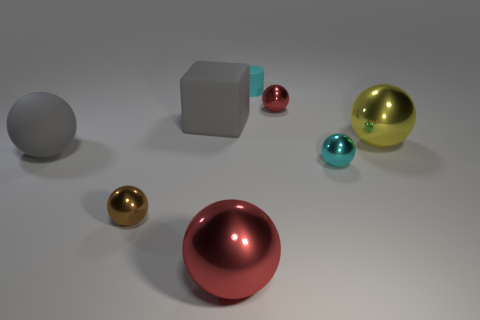Add 2 small red metallic spheres. How many objects exist? 10 Subtract all red blocks. How many red balls are left? 2 Subtract all gray rubber spheres. How many spheres are left? 5 Subtract all gray balls. How many balls are left? 5 Subtract 1 spheres. How many spheres are left? 5 Subtract all blocks. How many objects are left? 7 Subtract 1 cyan balls. How many objects are left? 7 Subtract all brown balls. Subtract all yellow cubes. How many balls are left? 5 Subtract all big yellow metal balls. Subtract all purple balls. How many objects are left? 7 Add 8 big gray rubber blocks. How many big gray rubber blocks are left? 9 